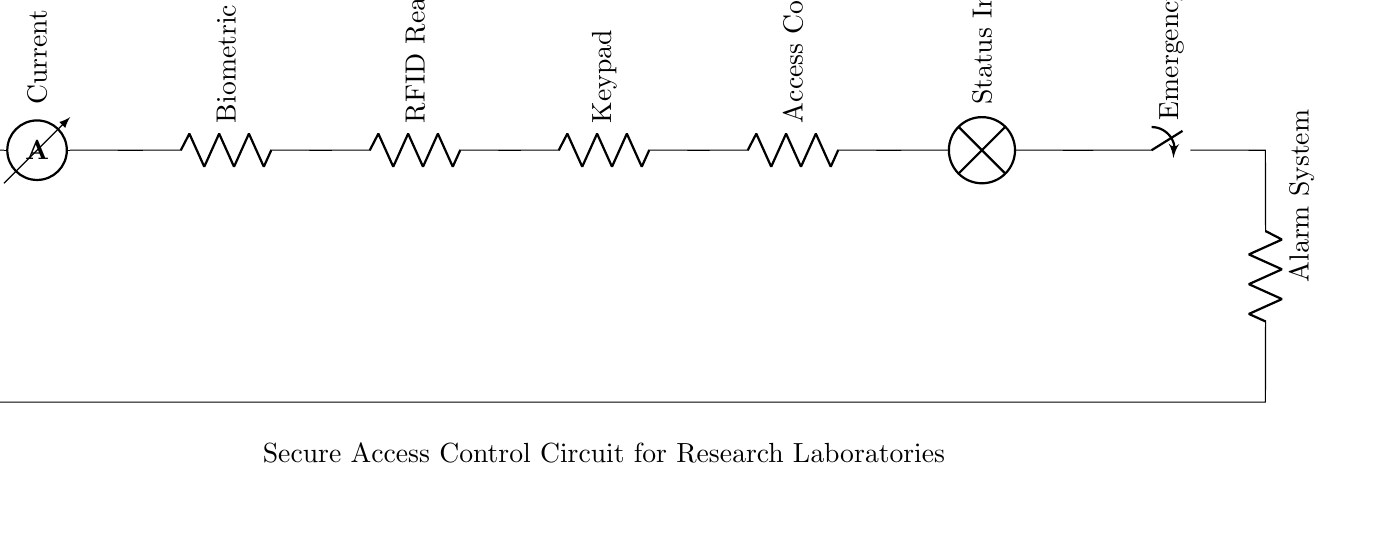What is the main power source of this circuit? The main power source is a battery, indicated by the label V_s. This component provides the necessary voltage for the circuit to operate.
Answer: battery How many resistive components are in the circuit? There are six resistive components depicted as R, which include the biometric scanner, RFID reader, keypad, access control unit, and alarm system.
Answer: six What component is used to indicate the status of the access control system? The status indicator is represented by a lamp, which informs users about the operational status of the security system.
Answer: lamp What is the function of the emergency override switch? The emergency override switch allows users to bypass the standard access control system in case of emergencies, thus enabling immediate access to the laboratory.
Answer: bypass access Which component monitors the current in the circuit? The current sensor is the component that monitors the flow of current, ensuring that the system operates within safe electrical parameters.
Answer: current sensor If a breach occurs, which component is activated as a response? The alarm system is activated in case of a breach, serving as a warning mechanism to alert personnel about unauthorized access attempts.
Answer: alarm system 